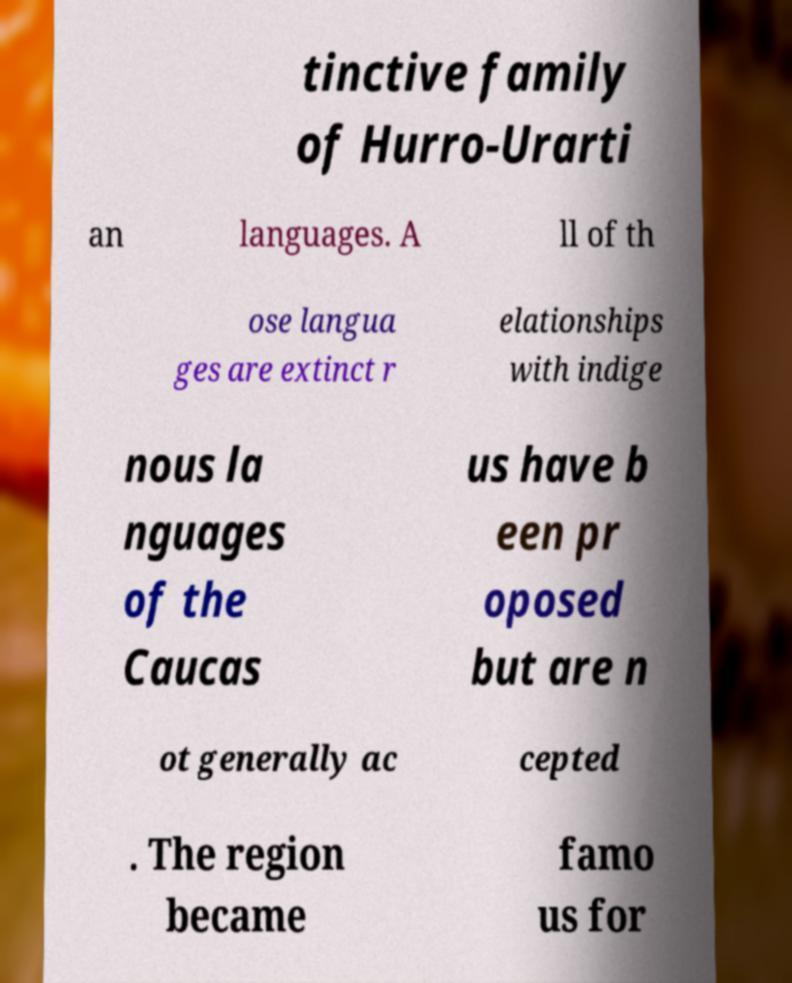For documentation purposes, I need the text within this image transcribed. Could you provide that? tinctive family of Hurro-Urarti an languages. A ll of th ose langua ges are extinct r elationships with indige nous la nguages of the Caucas us have b een pr oposed but are n ot generally ac cepted . The region became famo us for 